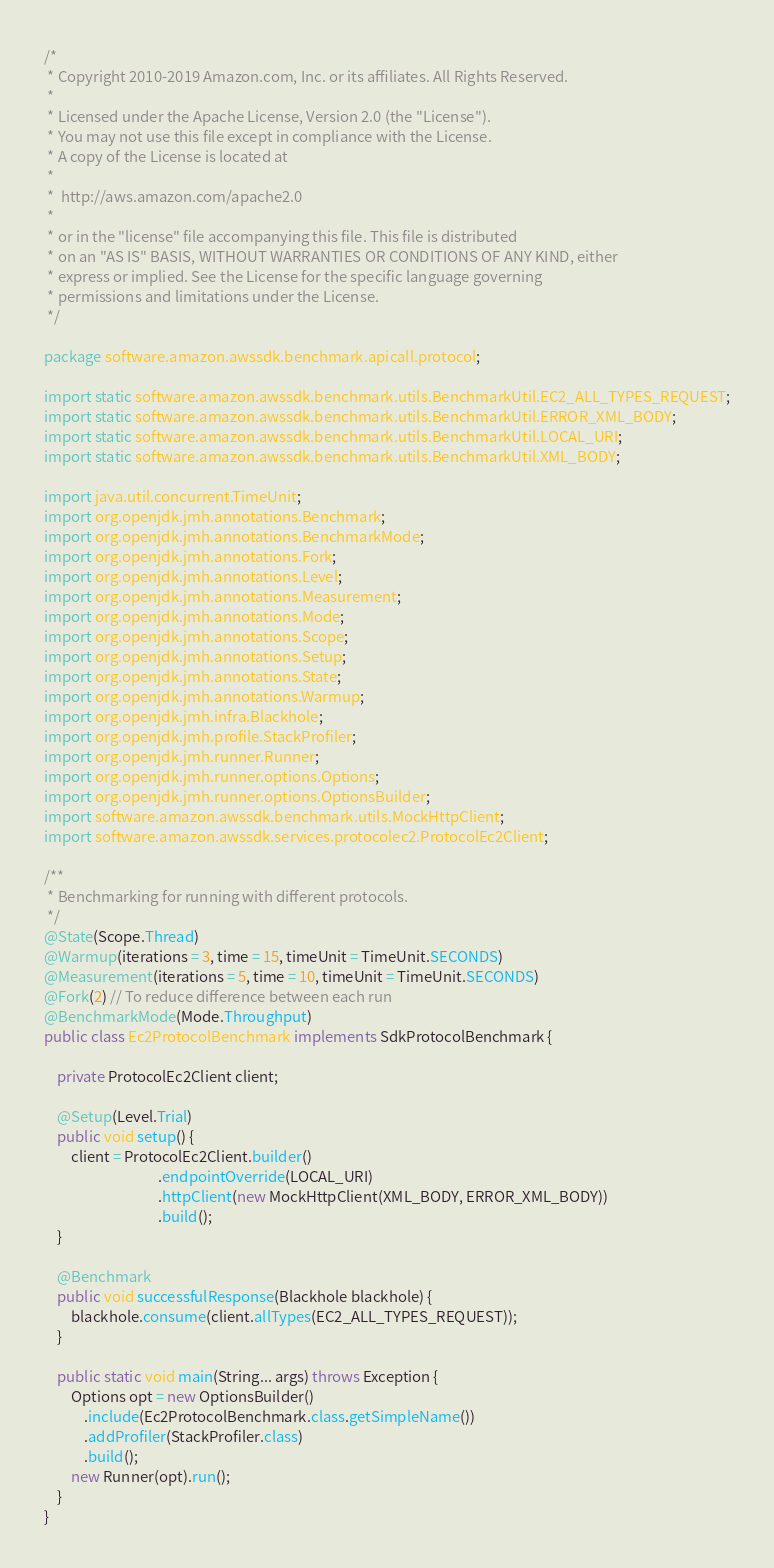Convert code to text. <code><loc_0><loc_0><loc_500><loc_500><_Java_>/*
 * Copyright 2010-2019 Amazon.com, Inc. or its affiliates. All Rights Reserved.
 *
 * Licensed under the Apache License, Version 2.0 (the "License").
 * You may not use this file except in compliance with the License.
 * A copy of the License is located at
 *
 *  http://aws.amazon.com/apache2.0
 *
 * or in the "license" file accompanying this file. This file is distributed
 * on an "AS IS" BASIS, WITHOUT WARRANTIES OR CONDITIONS OF ANY KIND, either
 * express or implied. See the License for the specific language governing
 * permissions and limitations under the License.
 */

package software.amazon.awssdk.benchmark.apicall.protocol;

import static software.amazon.awssdk.benchmark.utils.BenchmarkUtil.EC2_ALL_TYPES_REQUEST;
import static software.amazon.awssdk.benchmark.utils.BenchmarkUtil.ERROR_XML_BODY;
import static software.amazon.awssdk.benchmark.utils.BenchmarkUtil.LOCAL_URI;
import static software.amazon.awssdk.benchmark.utils.BenchmarkUtil.XML_BODY;

import java.util.concurrent.TimeUnit;
import org.openjdk.jmh.annotations.Benchmark;
import org.openjdk.jmh.annotations.BenchmarkMode;
import org.openjdk.jmh.annotations.Fork;
import org.openjdk.jmh.annotations.Level;
import org.openjdk.jmh.annotations.Measurement;
import org.openjdk.jmh.annotations.Mode;
import org.openjdk.jmh.annotations.Scope;
import org.openjdk.jmh.annotations.Setup;
import org.openjdk.jmh.annotations.State;
import org.openjdk.jmh.annotations.Warmup;
import org.openjdk.jmh.infra.Blackhole;
import org.openjdk.jmh.profile.StackProfiler;
import org.openjdk.jmh.runner.Runner;
import org.openjdk.jmh.runner.options.Options;
import org.openjdk.jmh.runner.options.OptionsBuilder;
import software.amazon.awssdk.benchmark.utils.MockHttpClient;
import software.amazon.awssdk.services.protocolec2.ProtocolEc2Client;

/**
 * Benchmarking for running with different protocols.
 */
@State(Scope.Thread)
@Warmup(iterations = 3, time = 15, timeUnit = TimeUnit.SECONDS)
@Measurement(iterations = 5, time = 10, timeUnit = TimeUnit.SECONDS)
@Fork(2) // To reduce difference between each run
@BenchmarkMode(Mode.Throughput)
public class Ec2ProtocolBenchmark implements SdkProtocolBenchmark {

    private ProtocolEc2Client client;

    @Setup(Level.Trial)
    public void setup() {
        client = ProtocolEc2Client.builder()
                                  .endpointOverride(LOCAL_URI)
                                  .httpClient(new MockHttpClient(XML_BODY, ERROR_XML_BODY))
                                  .build();
    }

    @Benchmark
    public void successfulResponse(Blackhole blackhole) {
        blackhole.consume(client.allTypes(EC2_ALL_TYPES_REQUEST));
    }

    public static void main(String... args) throws Exception {
        Options opt = new OptionsBuilder()
            .include(Ec2ProtocolBenchmark.class.getSimpleName())
            .addProfiler(StackProfiler.class)
            .build();
        new Runner(opt).run();
    }
}
</code> 